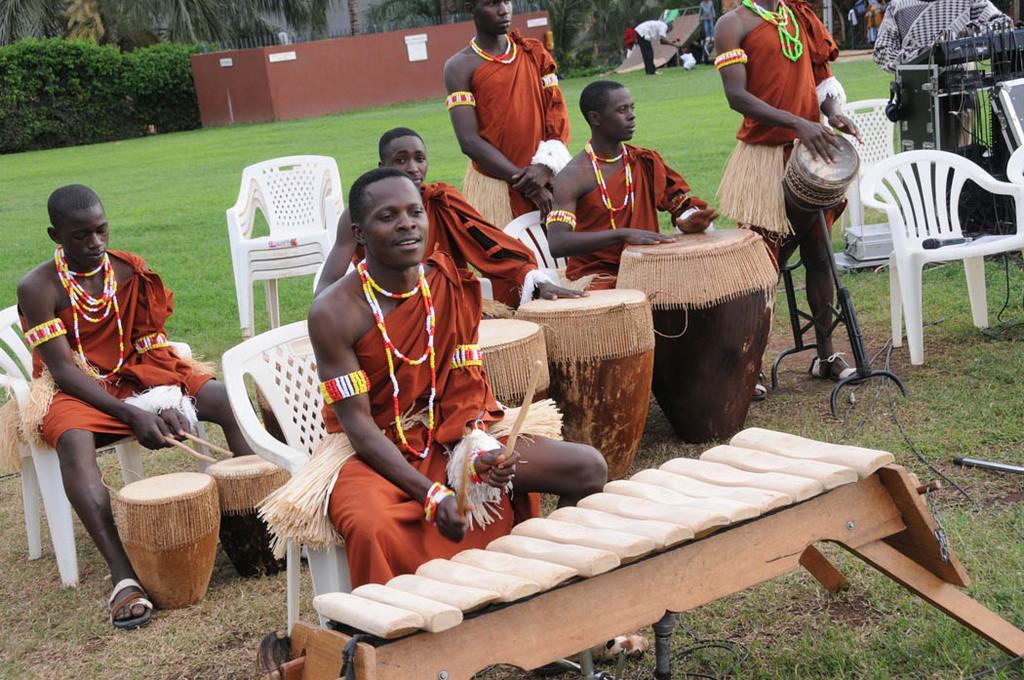What is happening in the image? There is a group of people in the image, and they are playing musical instruments. How are the people positioned while playing the instruments? The people are sitting on chairs while playing the instruments. What type of chicken can be seen playing the instruments in the image? There are no chickens present in the image, and therefore no such activity can be observed. 